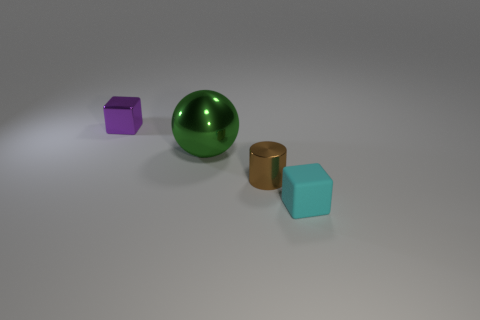Add 4 cyan matte cubes. How many objects exist? 8 Subtract all spheres. How many objects are left? 3 Subtract 0 red cylinders. How many objects are left? 4 Subtract all small green things. Subtract all green shiny spheres. How many objects are left? 3 Add 4 green metallic spheres. How many green metallic spheres are left? 5 Add 3 matte balls. How many matte balls exist? 3 